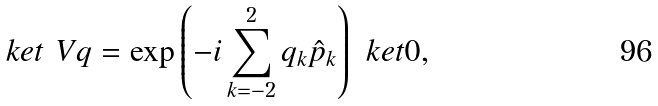Convert formula to latex. <formula><loc_0><loc_0><loc_500><loc_500>\ k e t { \ V q } = \exp \left ( - i \sum _ { k = - 2 } ^ { 2 } q _ { k } \hat { p } _ { k } \right ) \ k e t 0 ,</formula> 